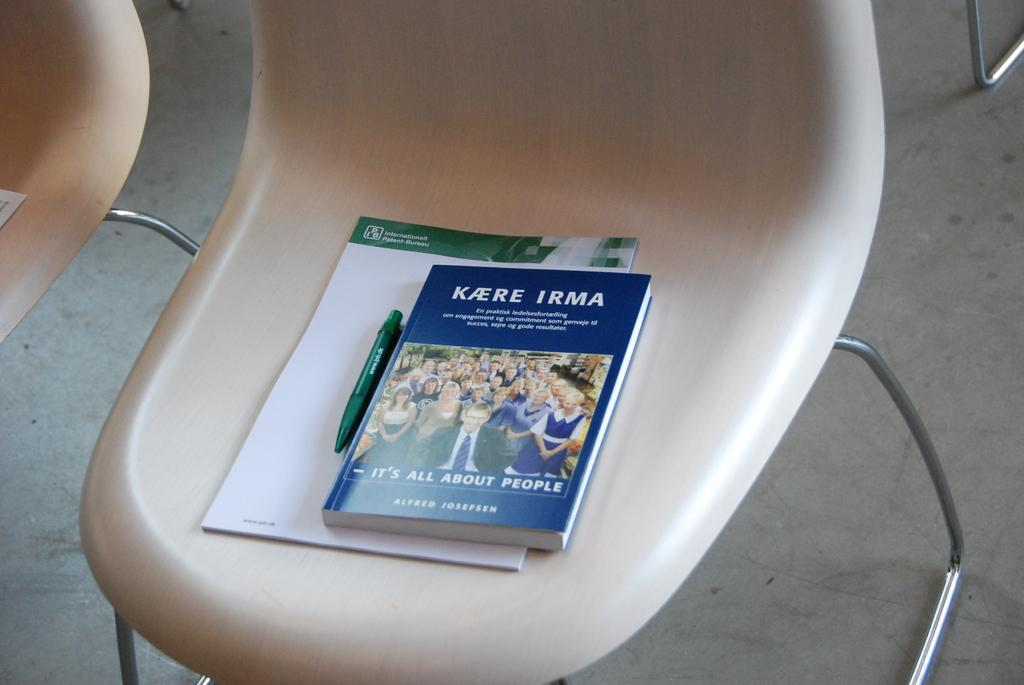<image>
Write a terse but informative summary of the picture. A book by Kaere Irma is on a chair with a notepad and pen. 